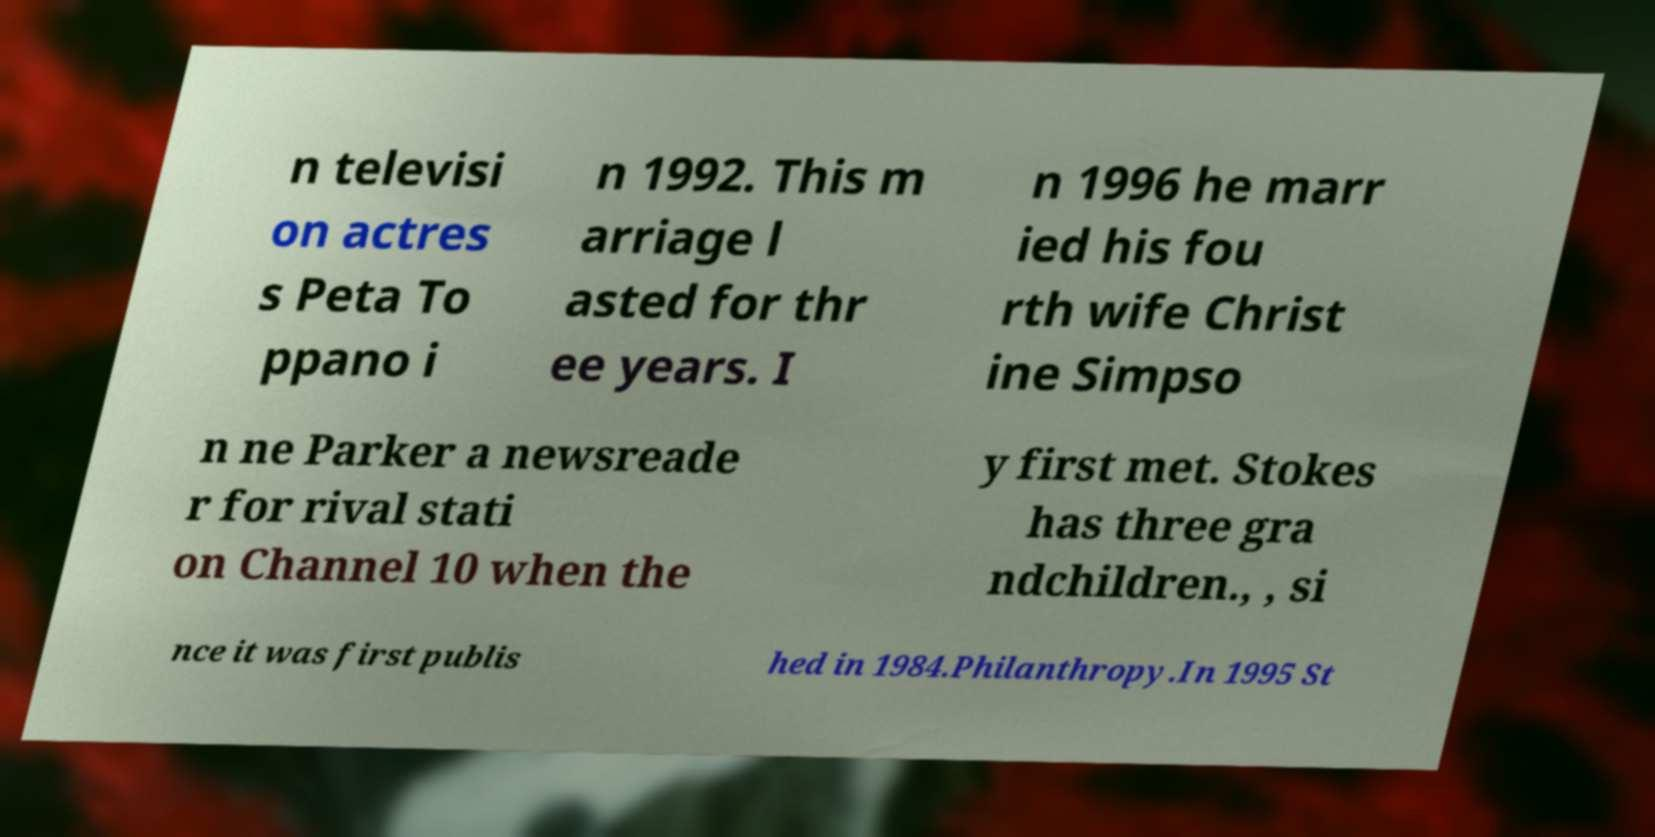Please read and relay the text visible in this image. What does it say? n televisi on actres s Peta To ppano i n 1992. This m arriage l asted for thr ee years. I n 1996 he marr ied his fou rth wife Christ ine Simpso n ne Parker a newsreade r for rival stati on Channel 10 when the y first met. Stokes has three gra ndchildren., , si nce it was first publis hed in 1984.Philanthropy.In 1995 St 